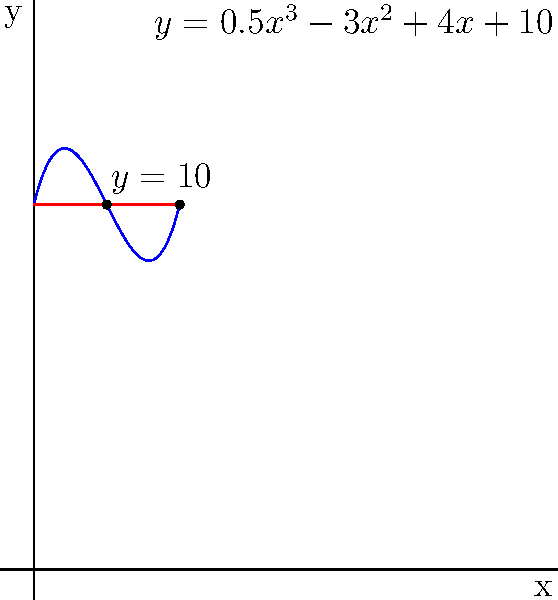A traditional Caribbean coconut drink is served in a uniquely shaped container. The cross-sectional area of the container at height x can be modeled by the function $A(x) = 0.5x^3 - 3x^2 + 4x + 10$ (in square inches), where x is the height in inches from the base. If the drink fills the container to a height of 4 inches, what is the volume of the drink in cubic inches? To find the volume of the drink, we need to integrate the cross-sectional area function from x = 0 to x = 4. Here's how we can solve this step-by-step:

1) The volume is given by the integral:
   $$V = \int_0^4 A(x) dx = \int_0^4 (0.5x^3 - 3x^2 + 4x + 10) dx$$

2) Integrate each term:
   $$V = [\frac{0.5x^4}{4} - x^3 + 2x^2 + 10x]_0^4$$

3) Evaluate at the upper and lower bounds:
   $$V = (\frac{0.5(4^4)}{4} - 4^3 + 2(4^2) + 10(4)) - (0 - 0 + 0 + 0)$$
   $$V = (32 - 64 + 32 + 40) - 0$$

4) Simplify:
   $$V = 40 \text{ cubic inches}$$

Therefore, the volume of the drink is 40 cubic inches.
Answer: 40 cubic inches 